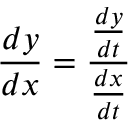Convert formula to latex. <formula><loc_0><loc_0><loc_500><loc_500>{ \frac { d y } { d x } } = { \frac { \frac { d y } { d t } } { \frac { d x } { d t } } }</formula> 